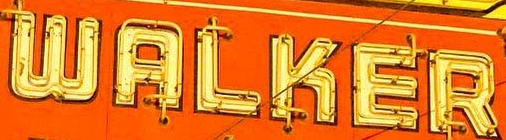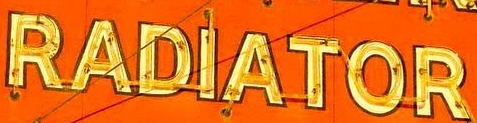What text appears in these images from left to right, separated by a semicolon? WALKER; RADIATOR 